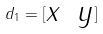Convert formula to latex. <formula><loc_0><loc_0><loc_500><loc_500>d _ { 1 } = [ \begin{matrix} x & y \\ \end{matrix} ]</formula> 